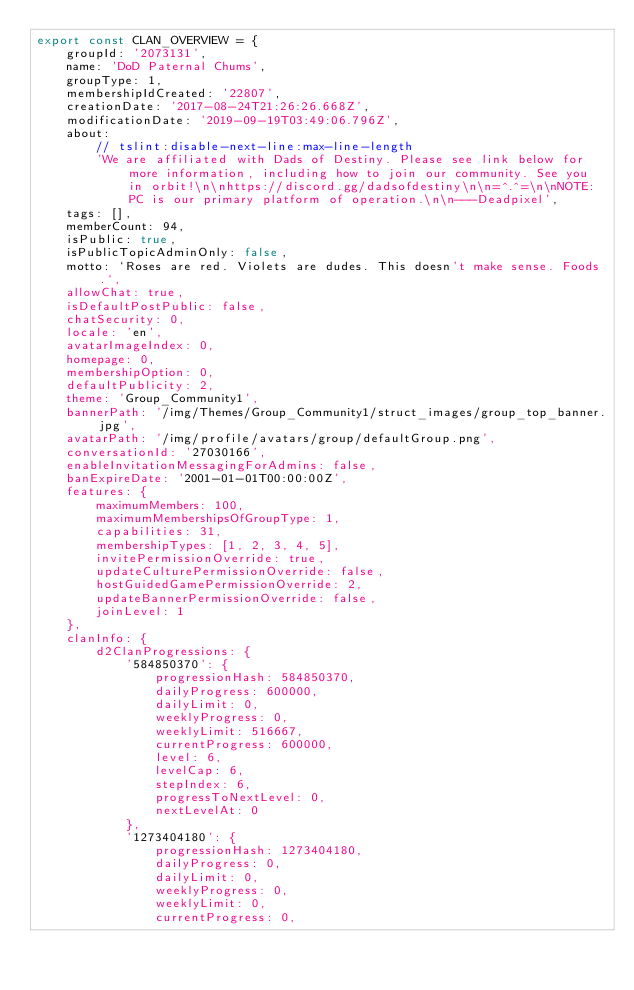Convert code to text. <code><loc_0><loc_0><loc_500><loc_500><_TypeScript_>export const CLAN_OVERVIEW = {
    groupId: '2073131',
    name: 'DoD Paternal Chums',
    groupType: 1,
    membershipIdCreated: '22807',
    creationDate: '2017-08-24T21:26:26.668Z',
    modificationDate: '2019-09-19T03:49:06.796Z',
    about:
        // tslint:disable-next-line:max-line-length
        'We are affiliated with Dads of Destiny. Please see link below for more information, including how to join our community. See you in orbit!\n\nhttps://discord.gg/dadsofdestiny\n\n=^.^=\n\nNOTE: PC is our primary platform of operation.\n\n---Deadpixel',
    tags: [],
    memberCount: 94,
    isPublic: true,
    isPublicTopicAdminOnly: false,
    motto: `Roses are red. Violets are dudes. This doesn't make sense. Foods.`,
    allowChat: true,
    isDefaultPostPublic: false,
    chatSecurity: 0,
    locale: 'en',
    avatarImageIndex: 0,
    homepage: 0,
    membershipOption: 0,
    defaultPublicity: 2,
    theme: 'Group_Community1',
    bannerPath: '/img/Themes/Group_Community1/struct_images/group_top_banner.jpg',
    avatarPath: '/img/profile/avatars/group/defaultGroup.png',
    conversationId: '27030166',
    enableInvitationMessagingForAdmins: false,
    banExpireDate: '2001-01-01T00:00:00Z',
    features: {
        maximumMembers: 100,
        maximumMembershipsOfGroupType: 1,
        capabilities: 31,
        membershipTypes: [1, 2, 3, 4, 5],
        invitePermissionOverride: true,
        updateCulturePermissionOverride: false,
        hostGuidedGamePermissionOverride: 2,
        updateBannerPermissionOverride: false,
        joinLevel: 1
    },
    clanInfo: {
        d2ClanProgressions: {
            '584850370': {
                progressionHash: 584850370,
                dailyProgress: 600000,
                dailyLimit: 0,
                weeklyProgress: 0,
                weeklyLimit: 516667,
                currentProgress: 600000,
                level: 6,
                levelCap: 6,
                stepIndex: 6,
                progressToNextLevel: 0,
                nextLevelAt: 0
            },
            '1273404180': {
                progressionHash: 1273404180,
                dailyProgress: 0,
                dailyLimit: 0,
                weeklyProgress: 0,
                weeklyLimit: 0,
                currentProgress: 0,</code> 